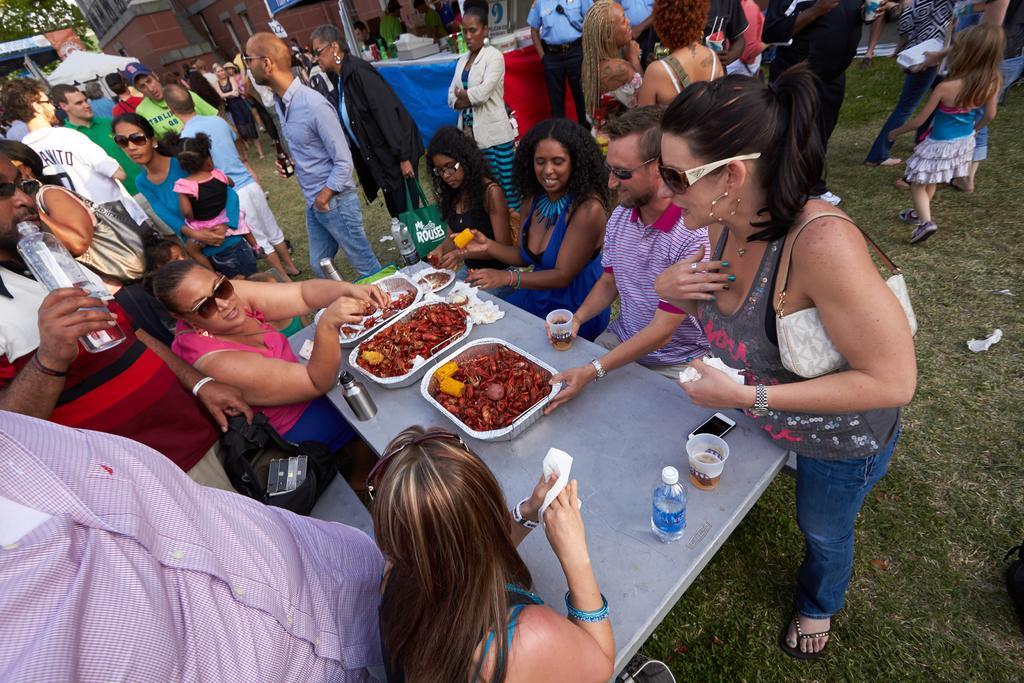Could you give a brief overview of what you see in this image? In this image we can see a group of persons and among them few people are holding objects. In the middle we can see a group of objects on a table. Behind the persons we can see a few objects on a table and a building. In the top left, we can see a tree. 